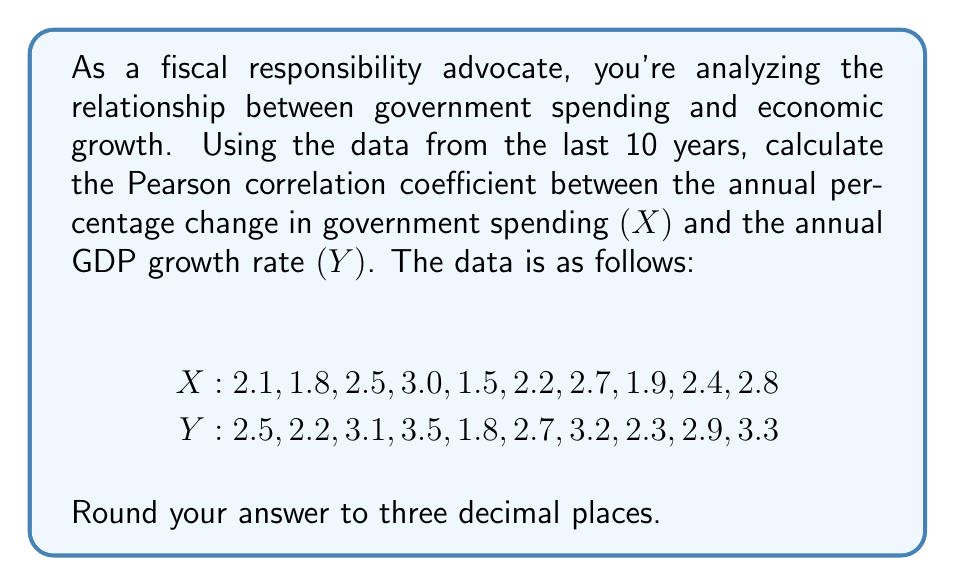Teach me how to tackle this problem. To calculate the Pearson correlation coefficient $(r)$ between government spending changes $(X)$ and GDP growth rates $(Y)$, we'll use the formula:

$$ r = \frac{\sum_{i=1}^{n} (x_i - \bar{x})(y_i - \bar{y})}{\sqrt{\sum_{i=1}^{n} (x_i - \bar{x})^2 \sum_{i=1}^{n} (y_i - \bar{y})^2}} $$

Where $\bar{x}$ and $\bar{y}$ are the means of $X$ and $Y$ respectively.

Step 1: Calculate the means
$\bar{x} = \frac{2.1 + 1.8 + 2.5 + 3.0 + 1.5 + 2.2 + 2.7 + 1.9 + 2.4 + 2.8}{10} = 2.29$
$\bar{y} = \frac{2.5 + 2.2 + 3.1 + 3.5 + 1.8 + 2.7 + 3.2 + 2.3 + 2.9 + 3.3}{10} = 2.75$

Step 2: Calculate $(x_i - \bar{x})$, $(y_i - \bar{y})$, $(x_i - \bar{x})^2$, $(y_i - \bar{y})^2$, and $(x_i - \bar{x})(y_i - \bar{y})$ for each pair

Step 3: Sum up the calculated values
$\sum (x_i - \bar{x})(y_i - \bar{y}) = 1.5375$
$\sum (x_i - \bar{x})^2 = 1.8390$
$\sum (y_i - \bar{y})^2 = 2.4650$

Step 4: Apply the formula
$$ r = \frac{1.5375}{\sqrt{1.8390 \times 2.4650}} = \frac{1.5375}{2.1271} = 0.7228 $$

Step 5: Round to three decimal places
$r \approx 0.723$
Answer: The Pearson correlation coefficient between the annual percentage change in government spending and the annual GDP growth rate is approximately 0.723. 